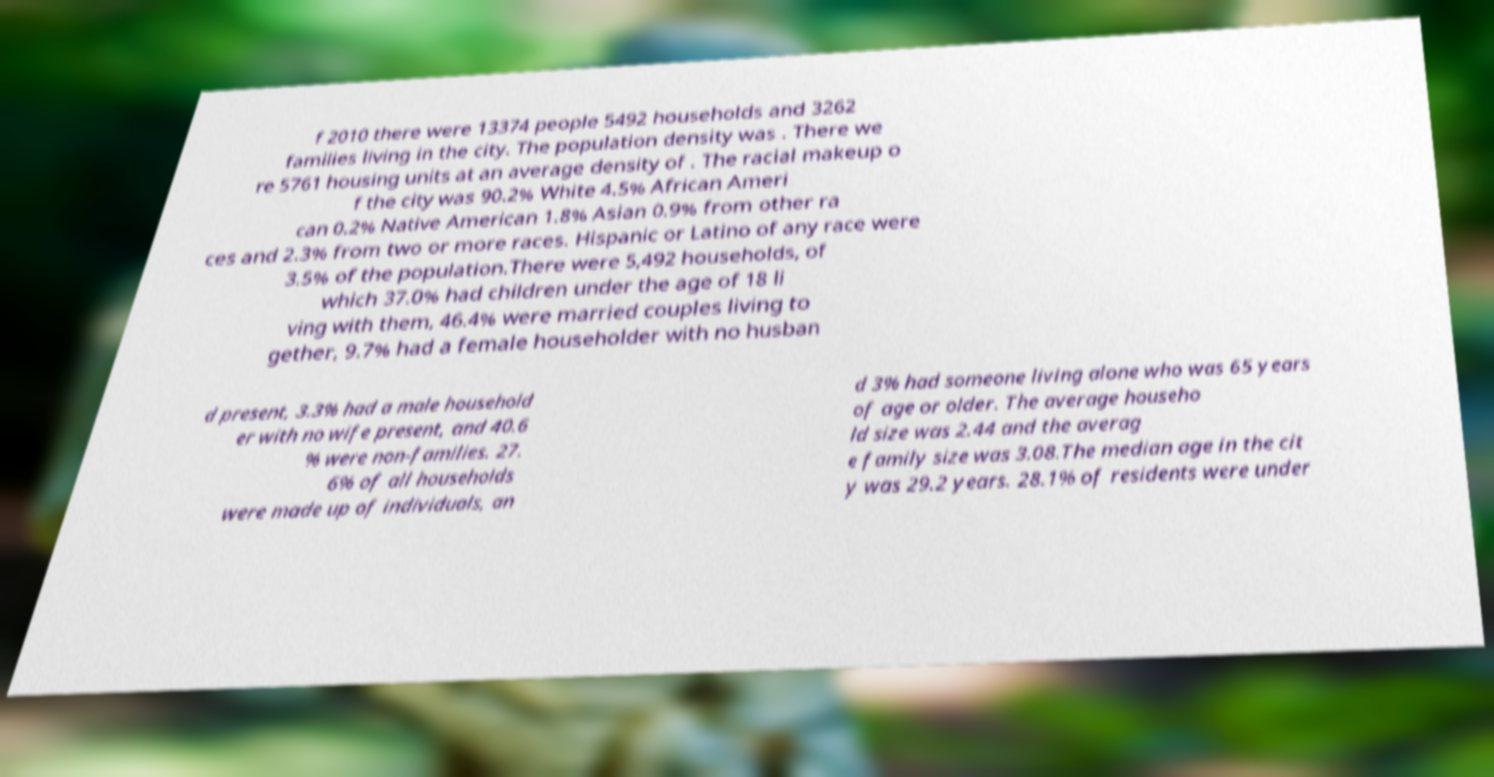For documentation purposes, I need the text within this image transcribed. Could you provide that? f 2010 there were 13374 people 5492 households and 3262 families living in the city. The population density was . There we re 5761 housing units at an average density of . The racial makeup o f the city was 90.2% White 4.5% African Ameri can 0.2% Native American 1.8% Asian 0.9% from other ra ces and 2.3% from two or more races. Hispanic or Latino of any race were 3.5% of the population.There were 5,492 households, of which 37.0% had children under the age of 18 li ving with them, 46.4% were married couples living to gether, 9.7% had a female householder with no husban d present, 3.3% had a male household er with no wife present, and 40.6 % were non-families. 27. 6% of all households were made up of individuals, an d 3% had someone living alone who was 65 years of age or older. The average househo ld size was 2.44 and the averag e family size was 3.08.The median age in the cit y was 29.2 years. 28.1% of residents were under 